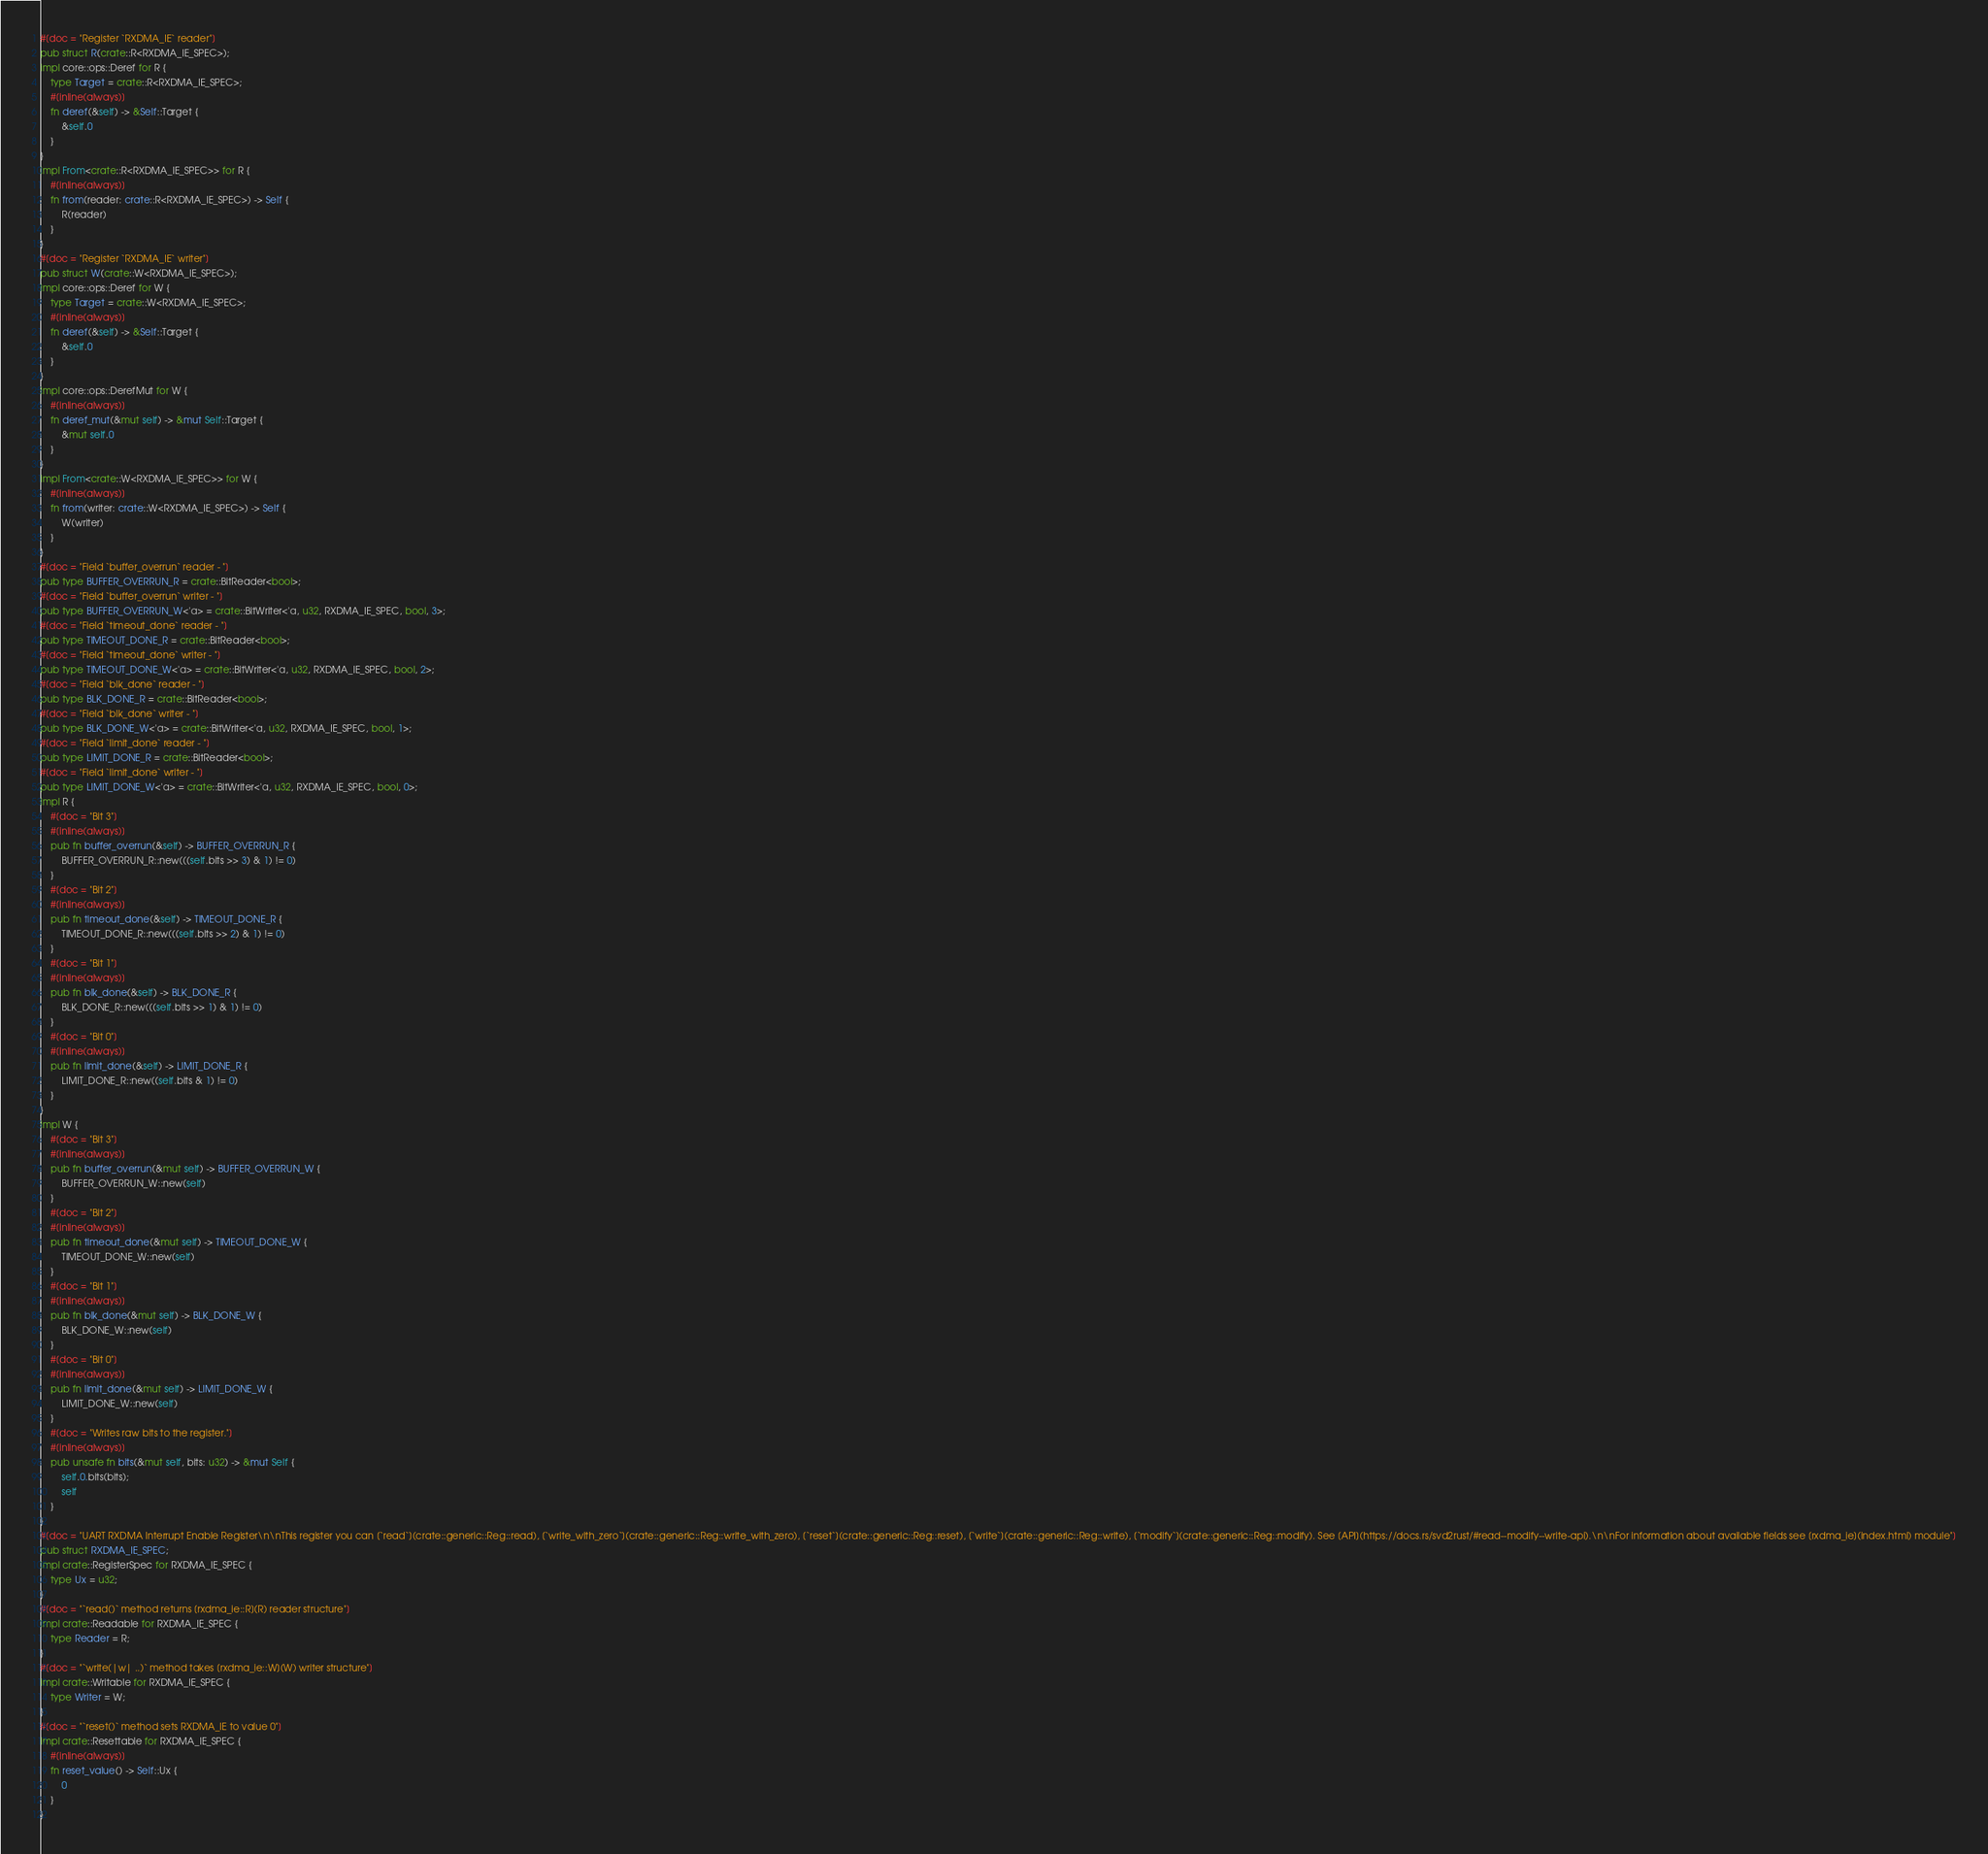<code> <loc_0><loc_0><loc_500><loc_500><_Rust_>#[doc = "Register `RXDMA_IE` reader"]
pub struct R(crate::R<RXDMA_IE_SPEC>);
impl core::ops::Deref for R {
    type Target = crate::R<RXDMA_IE_SPEC>;
    #[inline(always)]
    fn deref(&self) -> &Self::Target {
        &self.0
    }
}
impl From<crate::R<RXDMA_IE_SPEC>> for R {
    #[inline(always)]
    fn from(reader: crate::R<RXDMA_IE_SPEC>) -> Self {
        R(reader)
    }
}
#[doc = "Register `RXDMA_IE` writer"]
pub struct W(crate::W<RXDMA_IE_SPEC>);
impl core::ops::Deref for W {
    type Target = crate::W<RXDMA_IE_SPEC>;
    #[inline(always)]
    fn deref(&self) -> &Self::Target {
        &self.0
    }
}
impl core::ops::DerefMut for W {
    #[inline(always)]
    fn deref_mut(&mut self) -> &mut Self::Target {
        &mut self.0
    }
}
impl From<crate::W<RXDMA_IE_SPEC>> for W {
    #[inline(always)]
    fn from(writer: crate::W<RXDMA_IE_SPEC>) -> Self {
        W(writer)
    }
}
#[doc = "Field `buffer_overrun` reader - "]
pub type BUFFER_OVERRUN_R = crate::BitReader<bool>;
#[doc = "Field `buffer_overrun` writer - "]
pub type BUFFER_OVERRUN_W<'a> = crate::BitWriter<'a, u32, RXDMA_IE_SPEC, bool, 3>;
#[doc = "Field `timeout_done` reader - "]
pub type TIMEOUT_DONE_R = crate::BitReader<bool>;
#[doc = "Field `timeout_done` writer - "]
pub type TIMEOUT_DONE_W<'a> = crate::BitWriter<'a, u32, RXDMA_IE_SPEC, bool, 2>;
#[doc = "Field `blk_done` reader - "]
pub type BLK_DONE_R = crate::BitReader<bool>;
#[doc = "Field `blk_done` writer - "]
pub type BLK_DONE_W<'a> = crate::BitWriter<'a, u32, RXDMA_IE_SPEC, bool, 1>;
#[doc = "Field `limit_done` reader - "]
pub type LIMIT_DONE_R = crate::BitReader<bool>;
#[doc = "Field `limit_done` writer - "]
pub type LIMIT_DONE_W<'a> = crate::BitWriter<'a, u32, RXDMA_IE_SPEC, bool, 0>;
impl R {
    #[doc = "Bit 3"]
    #[inline(always)]
    pub fn buffer_overrun(&self) -> BUFFER_OVERRUN_R {
        BUFFER_OVERRUN_R::new(((self.bits >> 3) & 1) != 0)
    }
    #[doc = "Bit 2"]
    #[inline(always)]
    pub fn timeout_done(&self) -> TIMEOUT_DONE_R {
        TIMEOUT_DONE_R::new(((self.bits >> 2) & 1) != 0)
    }
    #[doc = "Bit 1"]
    #[inline(always)]
    pub fn blk_done(&self) -> BLK_DONE_R {
        BLK_DONE_R::new(((self.bits >> 1) & 1) != 0)
    }
    #[doc = "Bit 0"]
    #[inline(always)]
    pub fn limit_done(&self) -> LIMIT_DONE_R {
        LIMIT_DONE_R::new((self.bits & 1) != 0)
    }
}
impl W {
    #[doc = "Bit 3"]
    #[inline(always)]
    pub fn buffer_overrun(&mut self) -> BUFFER_OVERRUN_W {
        BUFFER_OVERRUN_W::new(self)
    }
    #[doc = "Bit 2"]
    #[inline(always)]
    pub fn timeout_done(&mut self) -> TIMEOUT_DONE_W {
        TIMEOUT_DONE_W::new(self)
    }
    #[doc = "Bit 1"]
    #[inline(always)]
    pub fn blk_done(&mut self) -> BLK_DONE_W {
        BLK_DONE_W::new(self)
    }
    #[doc = "Bit 0"]
    #[inline(always)]
    pub fn limit_done(&mut self) -> LIMIT_DONE_W {
        LIMIT_DONE_W::new(self)
    }
    #[doc = "Writes raw bits to the register."]
    #[inline(always)]
    pub unsafe fn bits(&mut self, bits: u32) -> &mut Self {
        self.0.bits(bits);
        self
    }
}
#[doc = "UART RXDMA Interrupt Enable Register\n\nThis register you can [`read`](crate::generic::Reg::read), [`write_with_zero`](crate::generic::Reg::write_with_zero), [`reset`](crate::generic::Reg::reset), [`write`](crate::generic::Reg::write), [`modify`](crate::generic::Reg::modify). See [API](https://docs.rs/svd2rust/#read--modify--write-api).\n\nFor information about available fields see [rxdma_ie](index.html) module"]
pub struct RXDMA_IE_SPEC;
impl crate::RegisterSpec for RXDMA_IE_SPEC {
    type Ux = u32;
}
#[doc = "`read()` method returns [rxdma_ie::R](R) reader structure"]
impl crate::Readable for RXDMA_IE_SPEC {
    type Reader = R;
}
#[doc = "`write(|w| ..)` method takes [rxdma_ie::W](W) writer structure"]
impl crate::Writable for RXDMA_IE_SPEC {
    type Writer = W;
}
#[doc = "`reset()` method sets RXDMA_IE to value 0"]
impl crate::Resettable for RXDMA_IE_SPEC {
    #[inline(always)]
    fn reset_value() -> Self::Ux {
        0
    }
}
</code> 